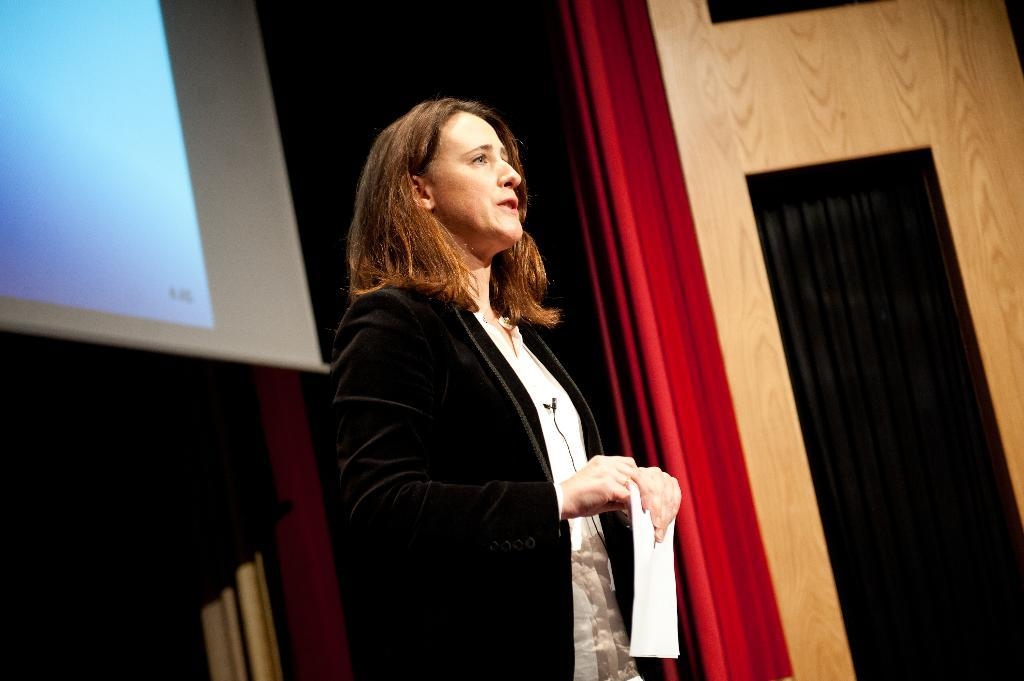Who is present in the image? There is a woman in the image. What is the woman holding in her hands? The woman is holding a paper in her hands. What can be seen in the background of the image? There are curtains and a projector screen in the background of the image. What type of jam is being used to write on the projector screen in the image? There is no jam present in the image, and the projector screen is not being used for writing. 